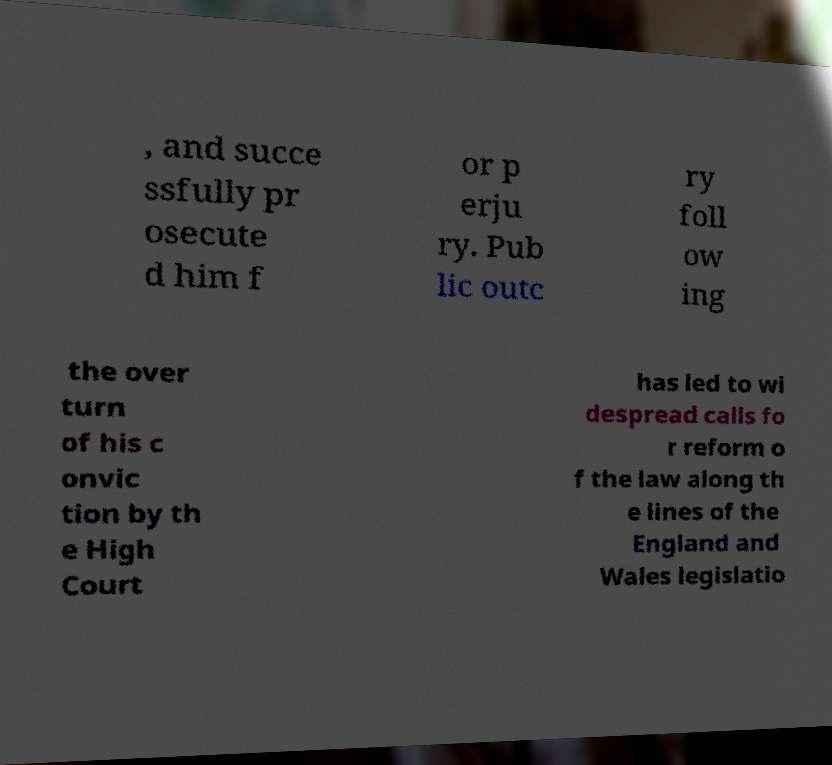Could you assist in decoding the text presented in this image and type it out clearly? , and succe ssfully pr osecute d him f or p erju ry. Pub lic outc ry foll ow ing the over turn of his c onvic tion by th e High Court has led to wi despread calls fo r reform o f the law along th e lines of the England and Wales legislatio 